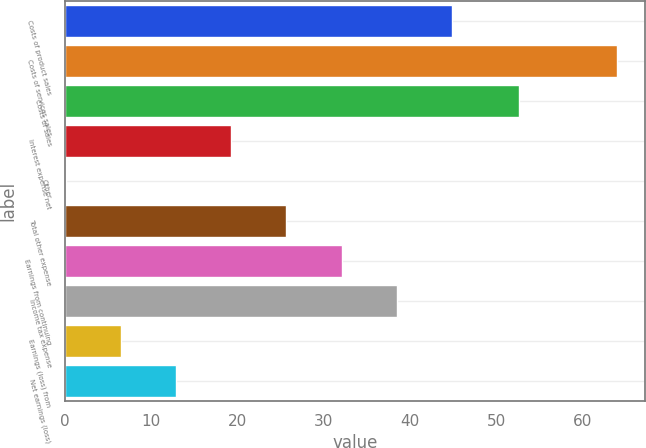<chart> <loc_0><loc_0><loc_500><loc_500><bar_chart><fcel>Costs of product sales<fcel>Costs of services sales<fcel>Costs of sales<fcel>Interest expense net<fcel>Other<fcel>Total other expense<fcel>Earnings from continuing<fcel>Income tax expense<fcel>Earnings (loss) from<fcel>Net earnings (loss)<nl><fcel>44.83<fcel>64<fcel>52.6<fcel>19.27<fcel>0.1<fcel>25.66<fcel>32.05<fcel>38.44<fcel>6.49<fcel>12.88<nl></chart> 